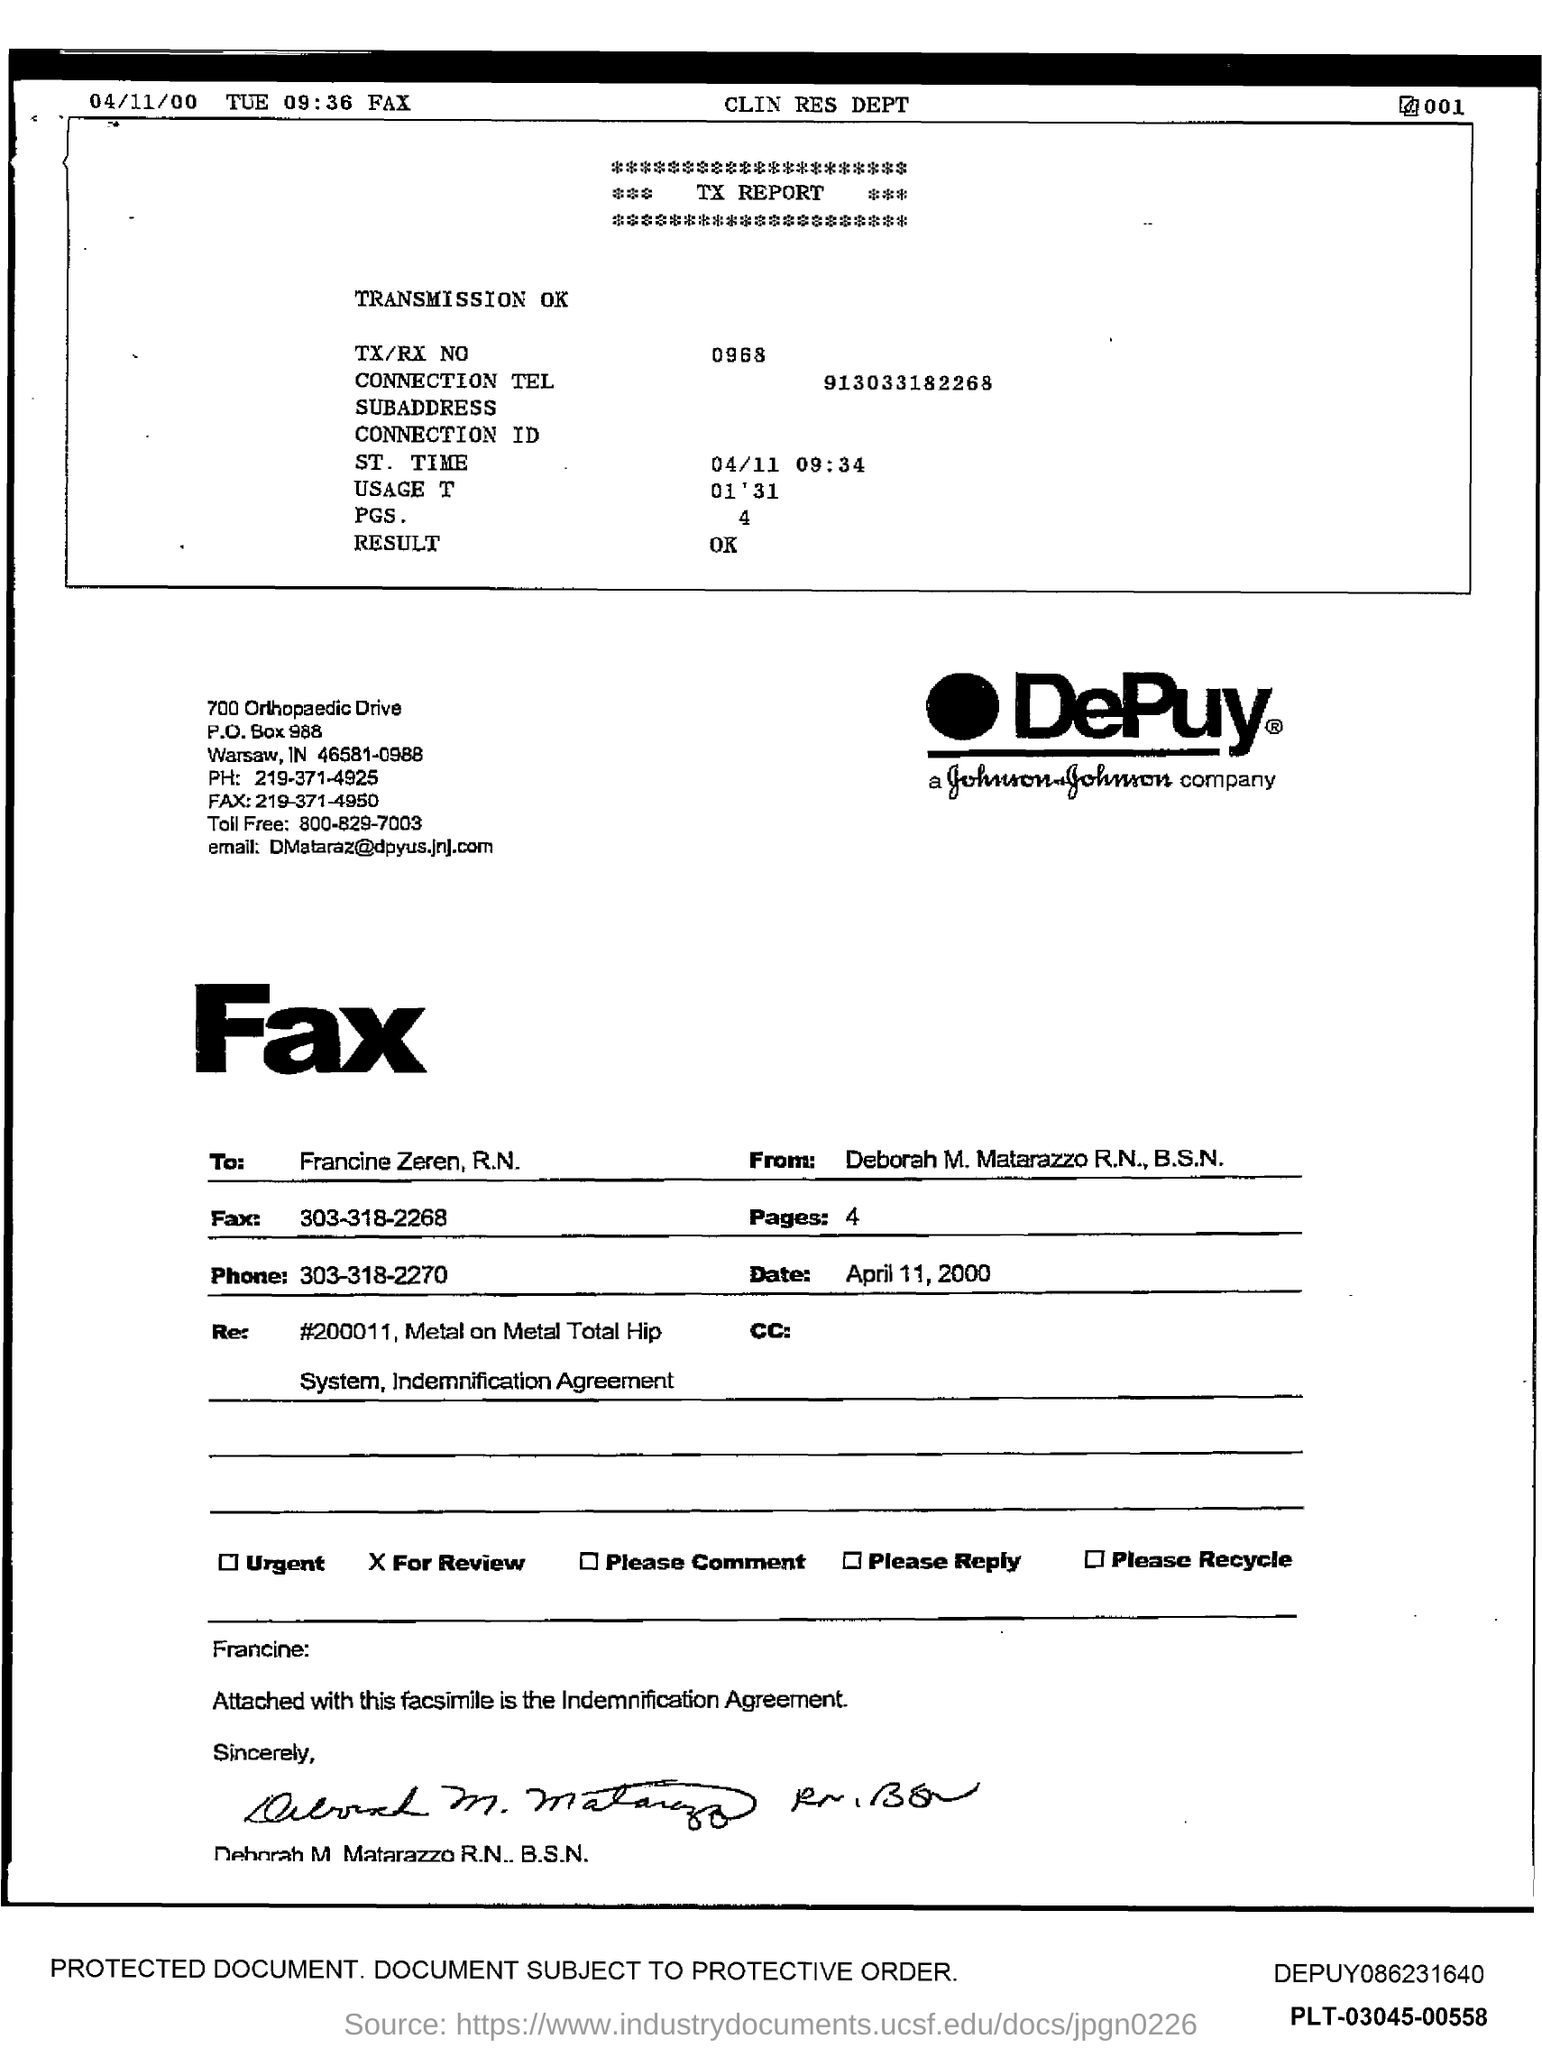Mention a couple of crucial points in this snapshot. The sender of the fax is Deborah M. Matarazzo R.N., B.S.N. The phone number mentioned in the fax is 303-318-2270. The connection mentioned in the TX report is 913033182268. The DePuy company logo is visible. The TX/RX No given in the TX report is 0968. 